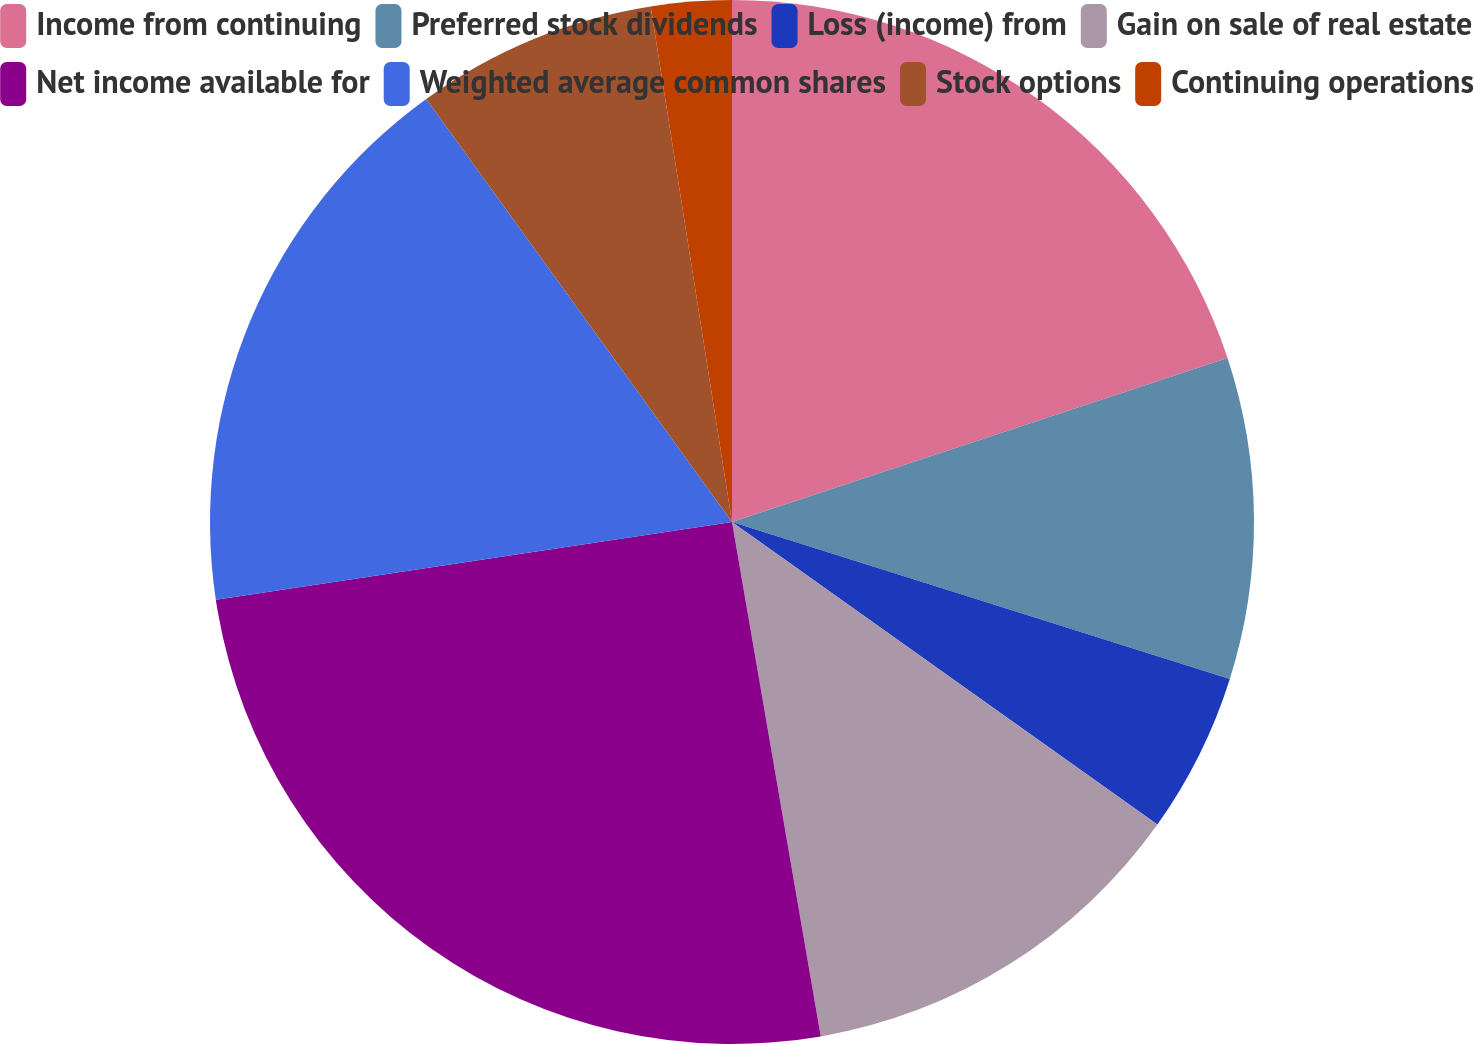Convert chart to OTSL. <chart><loc_0><loc_0><loc_500><loc_500><pie_chart><fcel>Income from continuing<fcel>Preferred stock dividends<fcel>Loss (income) from<fcel>Gain on sale of real estate<fcel>Net income available for<fcel>Weighted average common shares<fcel>Stock options<fcel>Continuing operations<nl><fcel>19.91%<fcel>9.95%<fcel>4.98%<fcel>12.44%<fcel>25.34%<fcel>17.42%<fcel>7.47%<fcel>2.49%<nl></chart> 